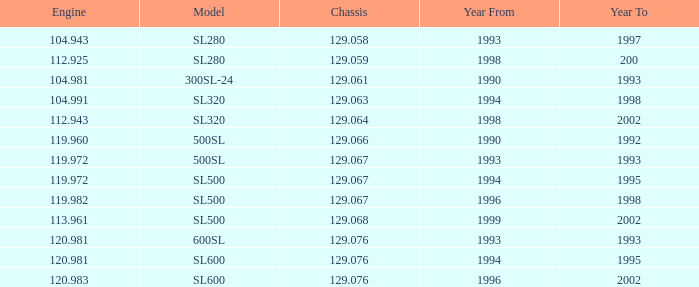Which Year To has an Engine of 119.972, and a Chassis smaller than 129.067? None. 